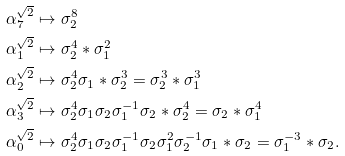<formula> <loc_0><loc_0><loc_500><loc_500>\alpha _ { 7 } ^ { \sqrt { 2 } } & \mapsto \sigma _ { 2 } ^ { 8 } \\ \alpha _ { 1 } ^ { \sqrt { 2 } } & \mapsto \sigma _ { 2 } ^ { 4 } * \sigma _ { 1 } ^ { 2 } \\ \alpha _ { 2 } ^ { \sqrt { 2 } } & \mapsto \sigma _ { 2 } ^ { 4 } \sigma _ { 1 } * \sigma _ { 2 } ^ { 3 } = \sigma _ { 2 } ^ { 3 } * \sigma _ { 1 } ^ { 3 } \\ \alpha _ { 3 } ^ { \sqrt { 2 } } & \mapsto \sigma _ { 2 } ^ { 4 } \sigma _ { 1 } \sigma _ { 2 } \sigma _ { 1 } ^ { - 1 } \sigma _ { 2 } * \sigma _ { 2 } ^ { 4 } = \sigma _ { 2 } * \sigma _ { 1 } ^ { 4 } \\ \alpha _ { 0 } ^ { \sqrt { 2 } } & \mapsto \sigma _ { 2 } ^ { 4 } \sigma _ { 1 } \sigma _ { 2 } \sigma _ { 1 } ^ { - 1 } \sigma _ { 2 } \sigma _ { 1 } ^ { 2 } \sigma _ { 2 } ^ { - 1 } \sigma _ { 1 } * \sigma _ { 2 } = \sigma _ { 1 } ^ { - 3 } * \sigma _ { 2 } .</formula> 